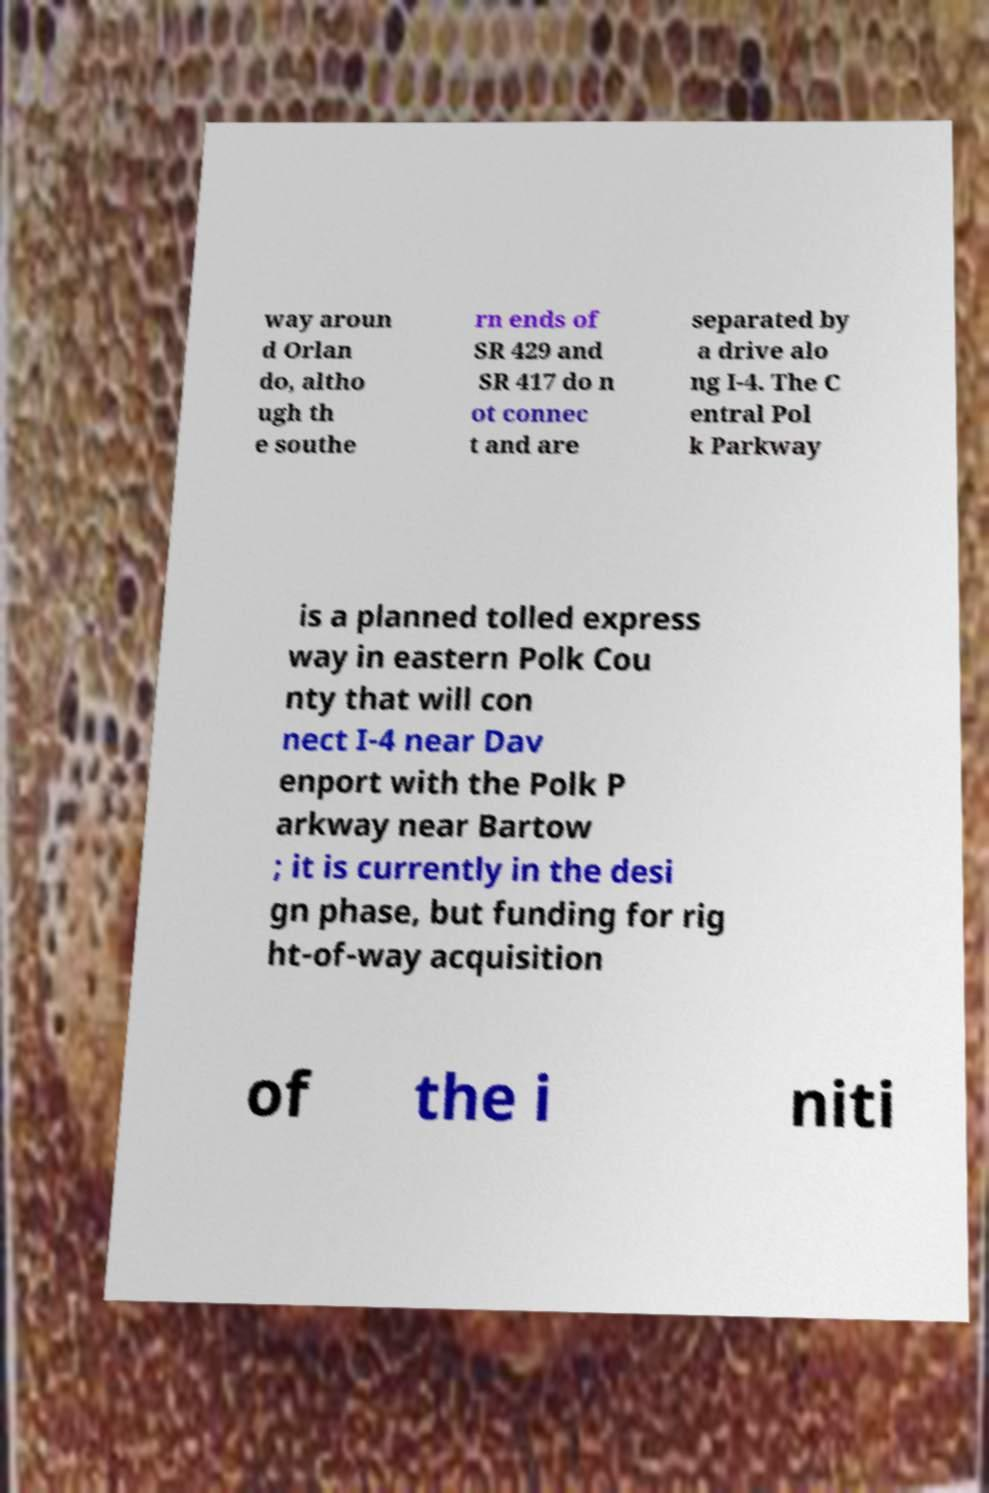Can you accurately transcribe the text from the provided image for me? way aroun d Orlan do, altho ugh th e southe rn ends of SR 429 and SR 417 do n ot connec t and are separated by a drive alo ng I-4. The C entral Pol k Parkway is a planned tolled express way in eastern Polk Cou nty that will con nect I-4 near Dav enport with the Polk P arkway near Bartow ; it is currently in the desi gn phase, but funding for rig ht-of-way acquisition of the i niti 